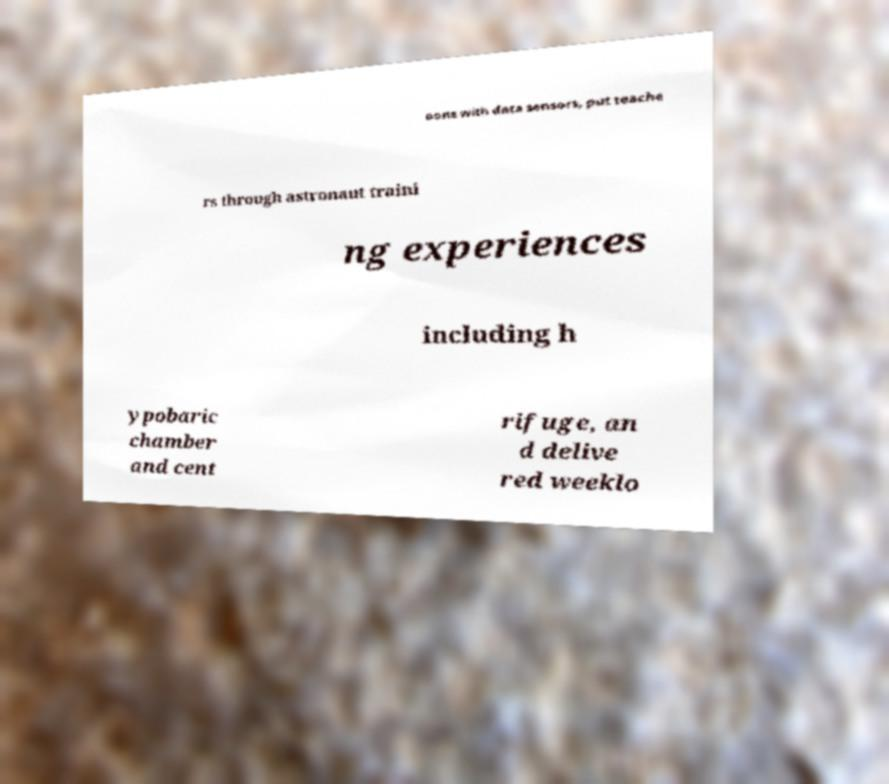Could you assist in decoding the text presented in this image and type it out clearly? oons with data sensors, put teache rs through astronaut traini ng experiences including h ypobaric chamber and cent rifuge, an d delive red weeklo 